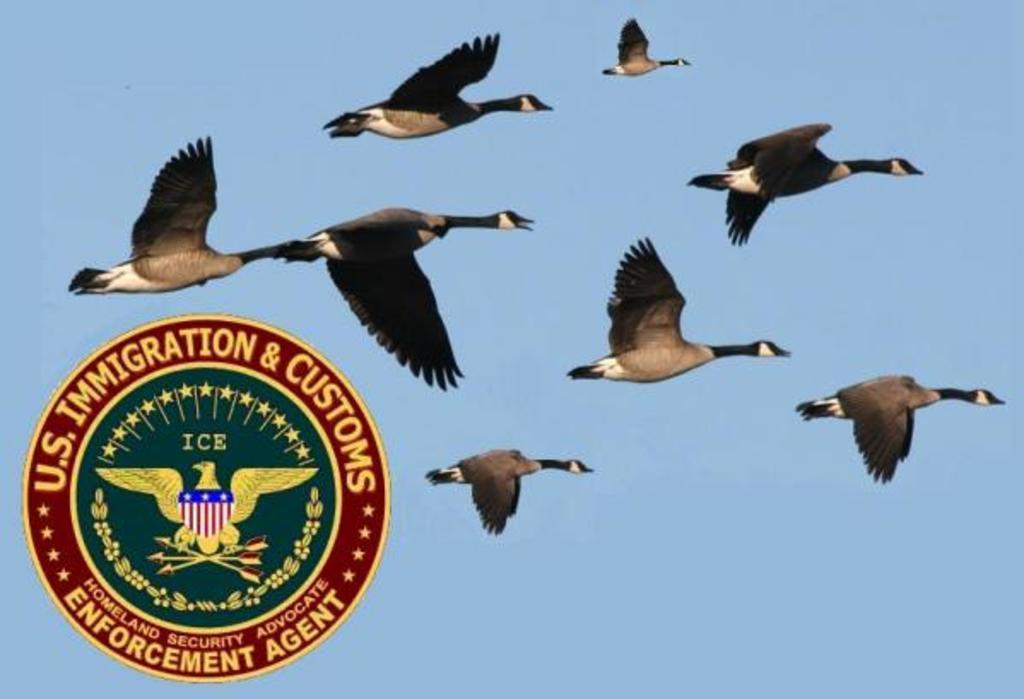Could you give a brief overview of what you see in this image? In the center of the picture there are birds flying. On the left there is a logo. Sky is sunny. 